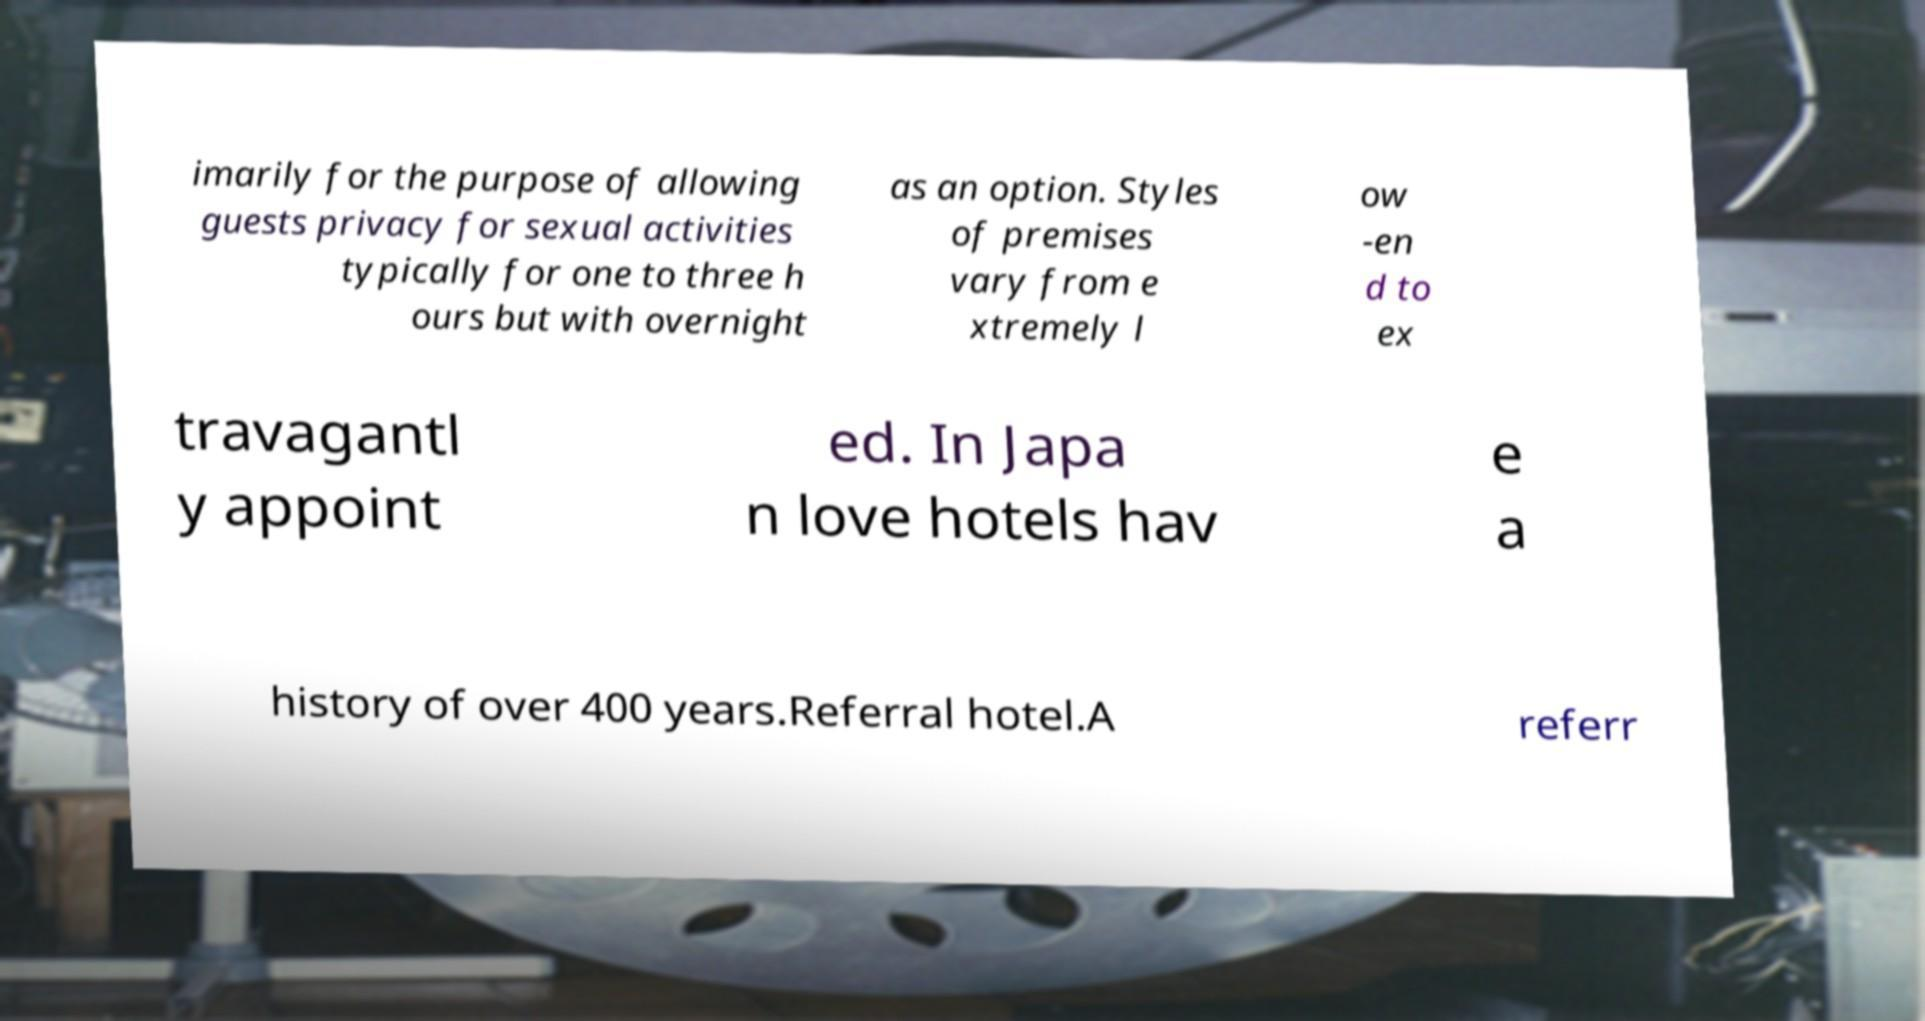Can you accurately transcribe the text from the provided image for me? imarily for the purpose of allowing guests privacy for sexual activities typically for one to three h ours but with overnight as an option. Styles of premises vary from e xtremely l ow -en d to ex travagantl y appoint ed. In Japa n love hotels hav e a history of over 400 years.Referral hotel.A referr 